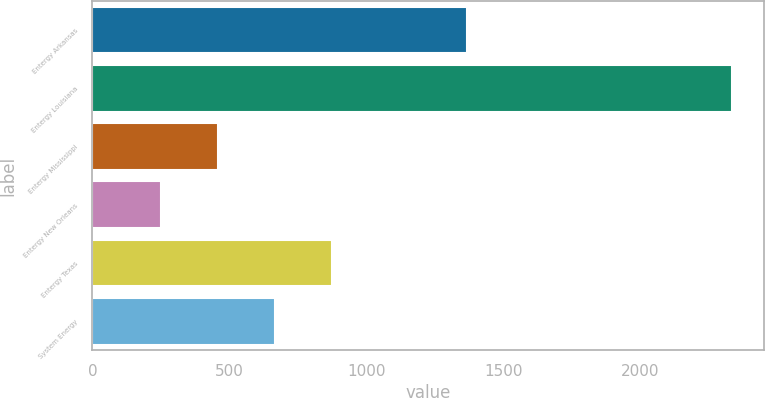<chart> <loc_0><loc_0><loc_500><loc_500><bar_chart><fcel>Entergy Arkansas<fcel>Entergy Louisiana<fcel>Entergy Mississippi<fcel>Entergy New Orleans<fcel>Entergy Texas<fcel>System Energy<nl><fcel>1369<fcel>2333<fcel>459.2<fcel>251<fcel>875.6<fcel>667.4<nl></chart> 